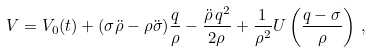Convert formula to latex. <formula><loc_0><loc_0><loc_500><loc_500>V = V _ { 0 } ( t ) + ( \sigma \ddot { \rho } - \rho \ddot { \sigma } ) \frac { q } { \rho } - \frac { \ddot { \rho } \, q ^ { 2 } } { 2 \rho } + \frac { 1 } { \rho ^ { 2 } } U \left ( \frac { q - \sigma } { \rho } \right ) \, ,</formula> 